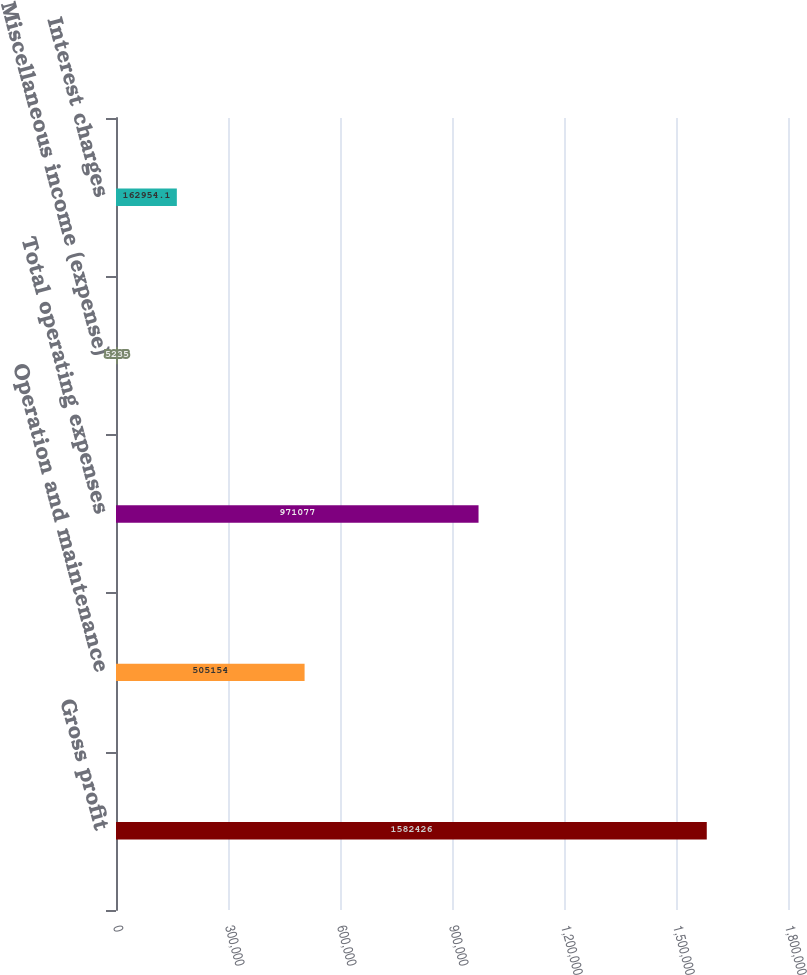Convert chart to OTSL. <chart><loc_0><loc_0><loc_500><loc_500><bar_chart><fcel>Gross profit<fcel>Operation and maintenance<fcel>Total operating expenses<fcel>Miscellaneous income (expense)<fcel>Interest charges<nl><fcel>1.58243e+06<fcel>505154<fcel>971077<fcel>5235<fcel>162954<nl></chart> 